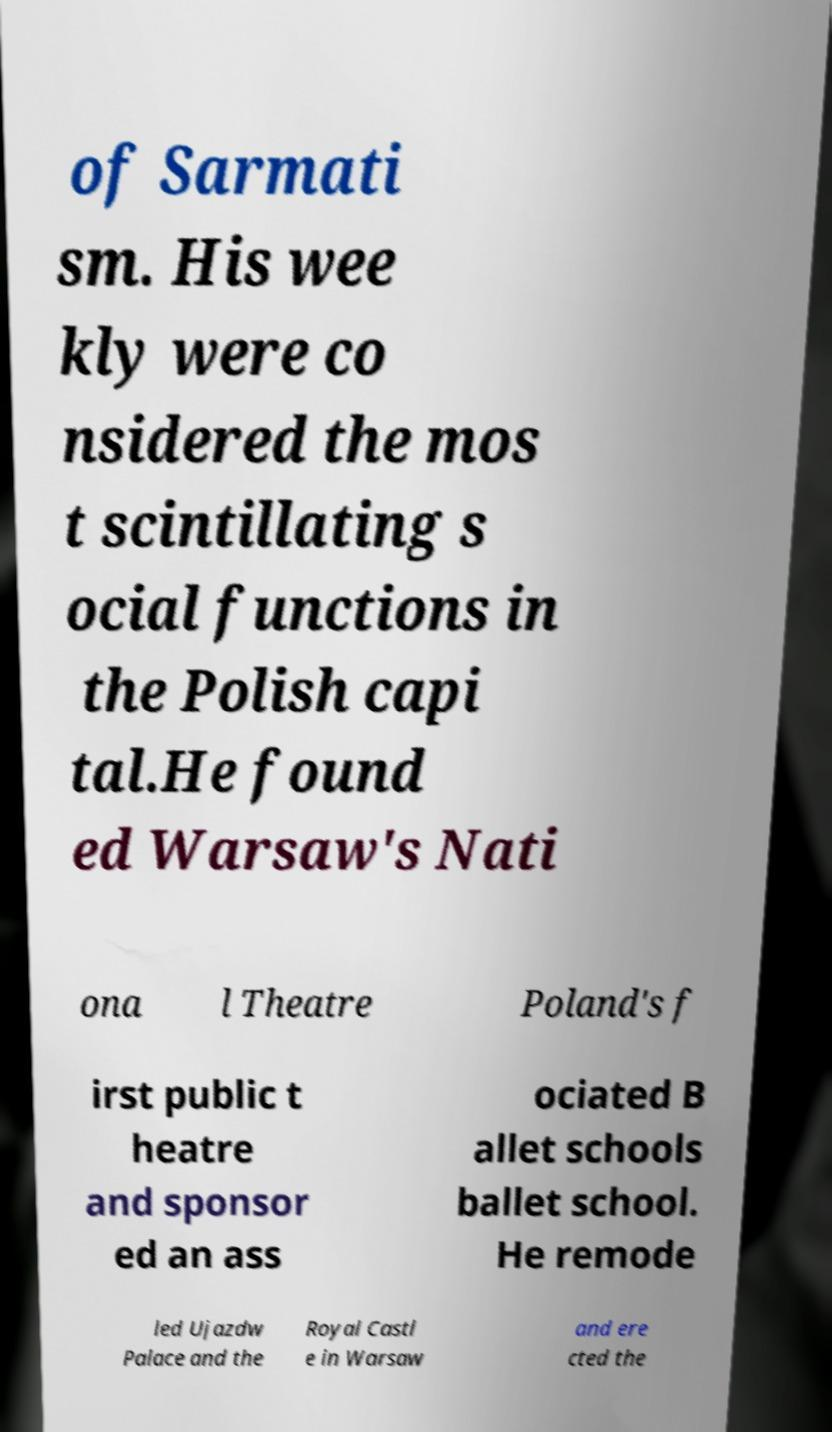Please read and relay the text visible in this image. What does it say? of Sarmati sm. His wee kly were co nsidered the mos t scintillating s ocial functions in the Polish capi tal.He found ed Warsaw's Nati ona l Theatre Poland's f irst public t heatre and sponsor ed an ass ociated B allet schools ballet school. He remode led Ujazdw Palace and the Royal Castl e in Warsaw and ere cted the 